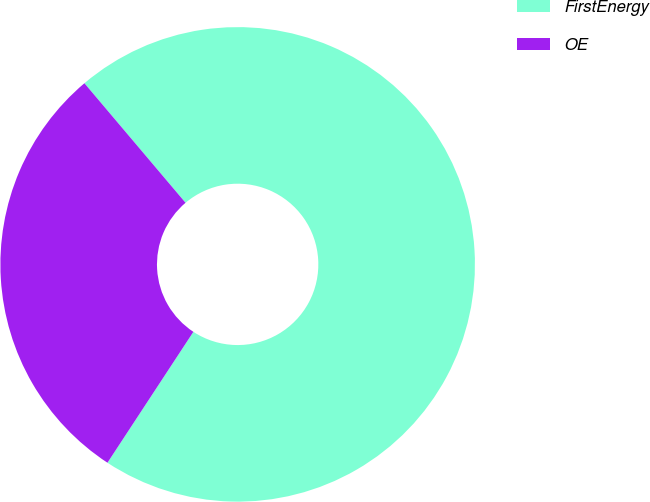Convert chart. <chart><loc_0><loc_0><loc_500><loc_500><pie_chart><fcel>FirstEnergy<fcel>OE<nl><fcel>70.42%<fcel>29.58%<nl></chart> 